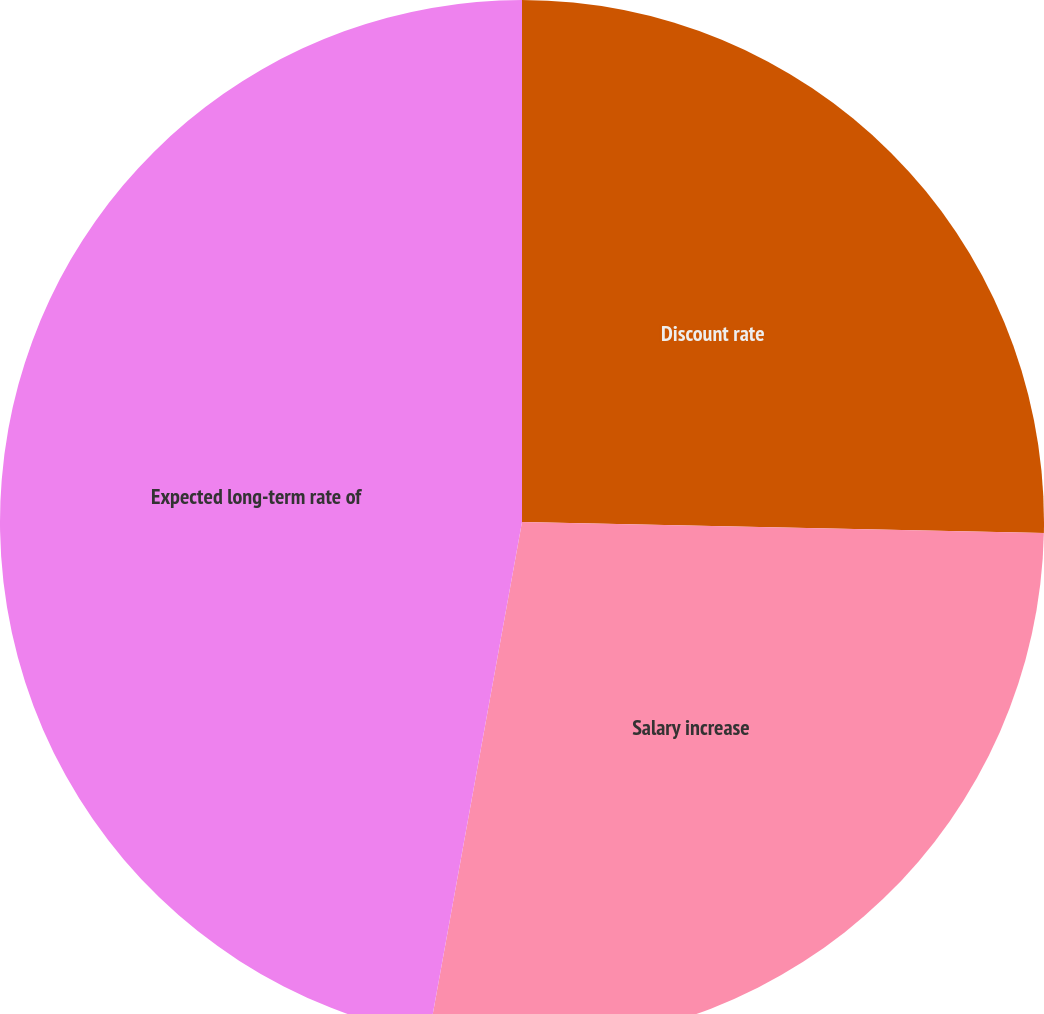Convert chart to OTSL. <chart><loc_0><loc_0><loc_500><loc_500><pie_chart><fcel>Discount rate<fcel>Salary increase<fcel>Expected long-term rate of<nl><fcel>25.34%<fcel>27.52%<fcel>47.15%<nl></chart> 